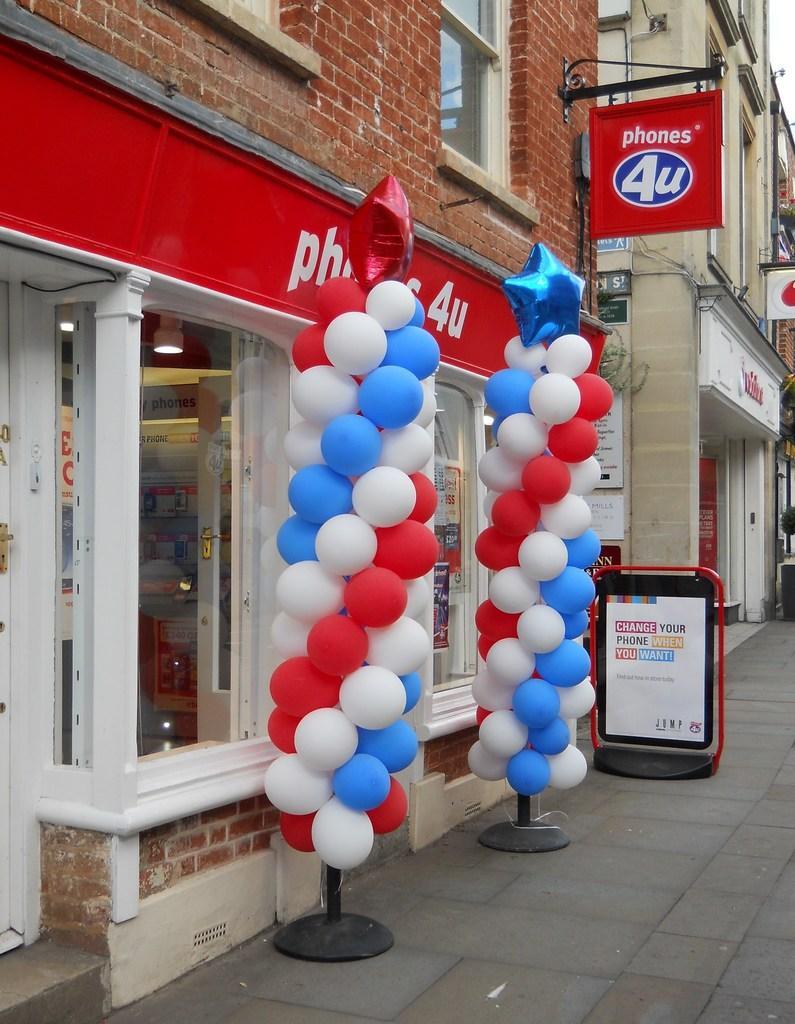Can you describe this image briefly? This picture shows few buildings and we see couple of advertisement board on the sidewalk and a advertisement board hanging to the wall and few balloons to the stand. 